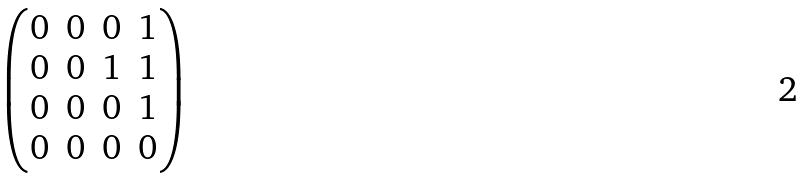Convert formula to latex. <formula><loc_0><loc_0><loc_500><loc_500>\begin{pmatrix} 0 & 0 & 0 & 1 \\ 0 & 0 & 1 & 1 \\ 0 & 0 & 0 & 1 \\ 0 & 0 & 0 & 0 \end{pmatrix}</formula> 